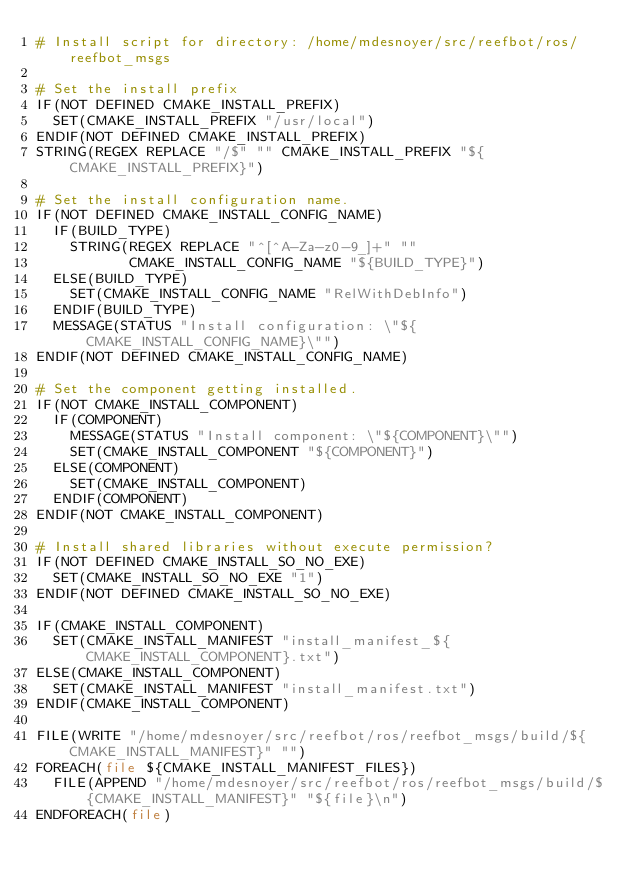Convert code to text. <code><loc_0><loc_0><loc_500><loc_500><_CMake_># Install script for directory: /home/mdesnoyer/src/reefbot/ros/reefbot_msgs

# Set the install prefix
IF(NOT DEFINED CMAKE_INSTALL_PREFIX)
  SET(CMAKE_INSTALL_PREFIX "/usr/local")
ENDIF(NOT DEFINED CMAKE_INSTALL_PREFIX)
STRING(REGEX REPLACE "/$" "" CMAKE_INSTALL_PREFIX "${CMAKE_INSTALL_PREFIX}")

# Set the install configuration name.
IF(NOT DEFINED CMAKE_INSTALL_CONFIG_NAME)
  IF(BUILD_TYPE)
    STRING(REGEX REPLACE "^[^A-Za-z0-9_]+" ""
           CMAKE_INSTALL_CONFIG_NAME "${BUILD_TYPE}")
  ELSE(BUILD_TYPE)
    SET(CMAKE_INSTALL_CONFIG_NAME "RelWithDebInfo")
  ENDIF(BUILD_TYPE)
  MESSAGE(STATUS "Install configuration: \"${CMAKE_INSTALL_CONFIG_NAME}\"")
ENDIF(NOT DEFINED CMAKE_INSTALL_CONFIG_NAME)

# Set the component getting installed.
IF(NOT CMAKE_INSTALL_COMPONENT)
  IF(COMPONENT)
    MESSAGE(STATUS "Install component: \"${COMPONENT}\"")
    SET(CMAKE_INSTALL_COMPONENT "${COMPONENT}")
  ELSE(COMPONENT)
    SET(CMAKE_INSTALL_COMPONENT)
  ENDIF(COMPONENT)
ENDIF(NOT CMAKE_INSTALL_COMPONENT)

# Install shared libraries without execute permission?
IF(NOT DEFINED CMAKE_INSTALL_SO_NO_EXE)
  SET(CMAKE_INSTALL_SO_NO_EXE "1")
ENDIF(NOT DEFINED CMAKE_INSTALL_SO_NO_EXE)

IF(CMAKE_INSTALL_COMPONENT)
  SET(CMAKE_INSTALL_MANIFEST "install_manifest_${CMAKE_INSTALL_COMPONENT}.txt")
ELSE(CMAKE_INSTALL_COMPONENT)
  SET(CMAKE_INSTALL_MANIFEST "install_manifest.txt")
ENDIF(CMAKE_INSTALL_COMPONENT)

FILE(WRITE "/home/mdesnoyer/src/reefbot/ros/reefbot_msgs/build/${CMAKE_INSTALL_MANIFEST}" "")
FOREACH(file ${CMAKE_INSTALL_MANIFEST_FILES})
  FILE(APPEND "/home/mdesnoyer/src/reefbot/ros/reefbot_msgs/build/${CMAKE_INSTALL_MANIFEST}" "${file}\n")
ENDFOREACH(file)
</code> 